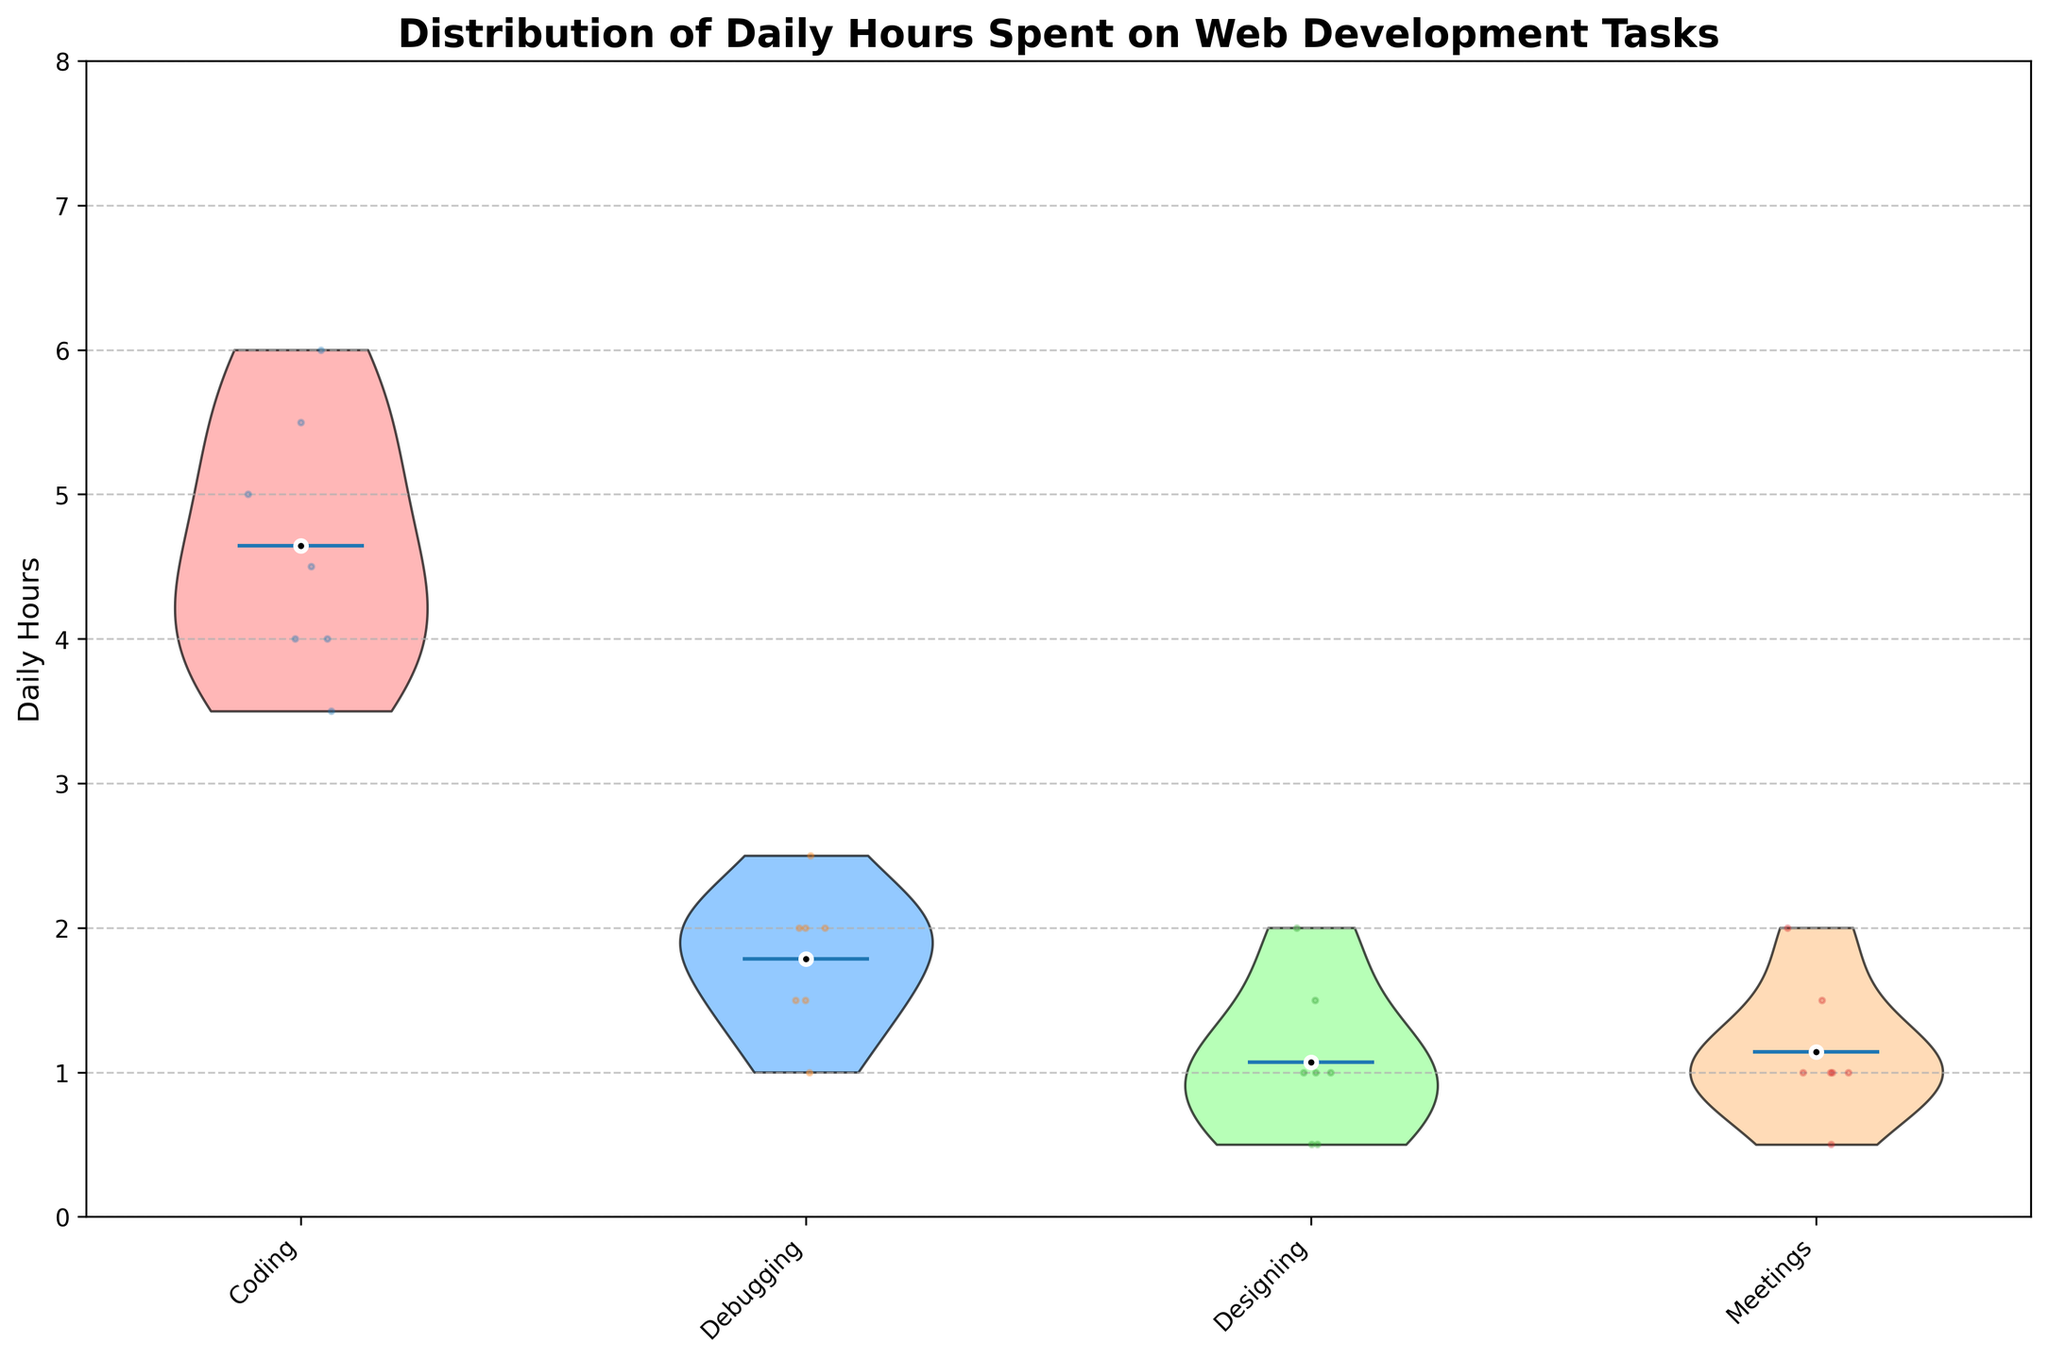What is the title of the figure? The title of the figure is displayed at the top of the plot, which describes the main topic or data being visualized. Here, the title is "Distribution of Daily Hours Spent on Web Development Tasks".
Answer: Distribution of Daily Hours Spent on Web Development Tasks How many different web development tasks are shown in the figure? The figure displays different categories along the x-axis, each representing a different web development task. By counting them, we can determine the number of tasks.
Answer: 4 What color is used to represent the 'Coding' task in the violin plot? Each task in the violin plot is represented by a different color. By looking at the color of the 'Coding' task near the x-axis labels, we can identify it.
Answer: #FF9999 (light red) What task has the highest mean daily hours spent? To identify this, look at the white dots on the violins, which represent the means. Compare their heights to see which is the highest.
Answer: Coding Which task shows the widest range of daily hours spent? The range in a violin plot is indicated by the spread of the "violin" shape. By comparing the widths of each of these shapes for all tasks, we can determine the task with the widest range.
Answer: Coding What is the mean daily hours spent on debugging? Find the white dot in the 'Debugging' violin, which represents the mean, and note its position on the y-axis. This indicates the mean daily hours.
Answer: Approximately 2 hours Are there any tasks where the mean daily hours spent is less than 1 hour? Identify the positions of the white dots on the violins and see if any of them fall below the 1-hour mark on the y-axis.
Answer: No Which task has the least variation in daily hours spent? To find this, observe which violin plot shows the narrowest spread (least width), indicating the smallest variability.
Answer: Meetings How do the daily hours spent on 'Designing' compare to those spent on 'Debugging'? Compare both the mean positions (white dots) and the spreads (widths) of the 'Designing' and 'Debugging' violins.
Answer: Debugging has a higher mean and a wider spread than Designing What is the total number of data points that were plotted across all tasks? Each developer's daily hours for each task is represented by a jittered data point around each violin plot. Summing up these points for all tasks gives the total number of data points. There are 7 developers and 4 tasks, so 7 x 4 data points.
Answer: 28 